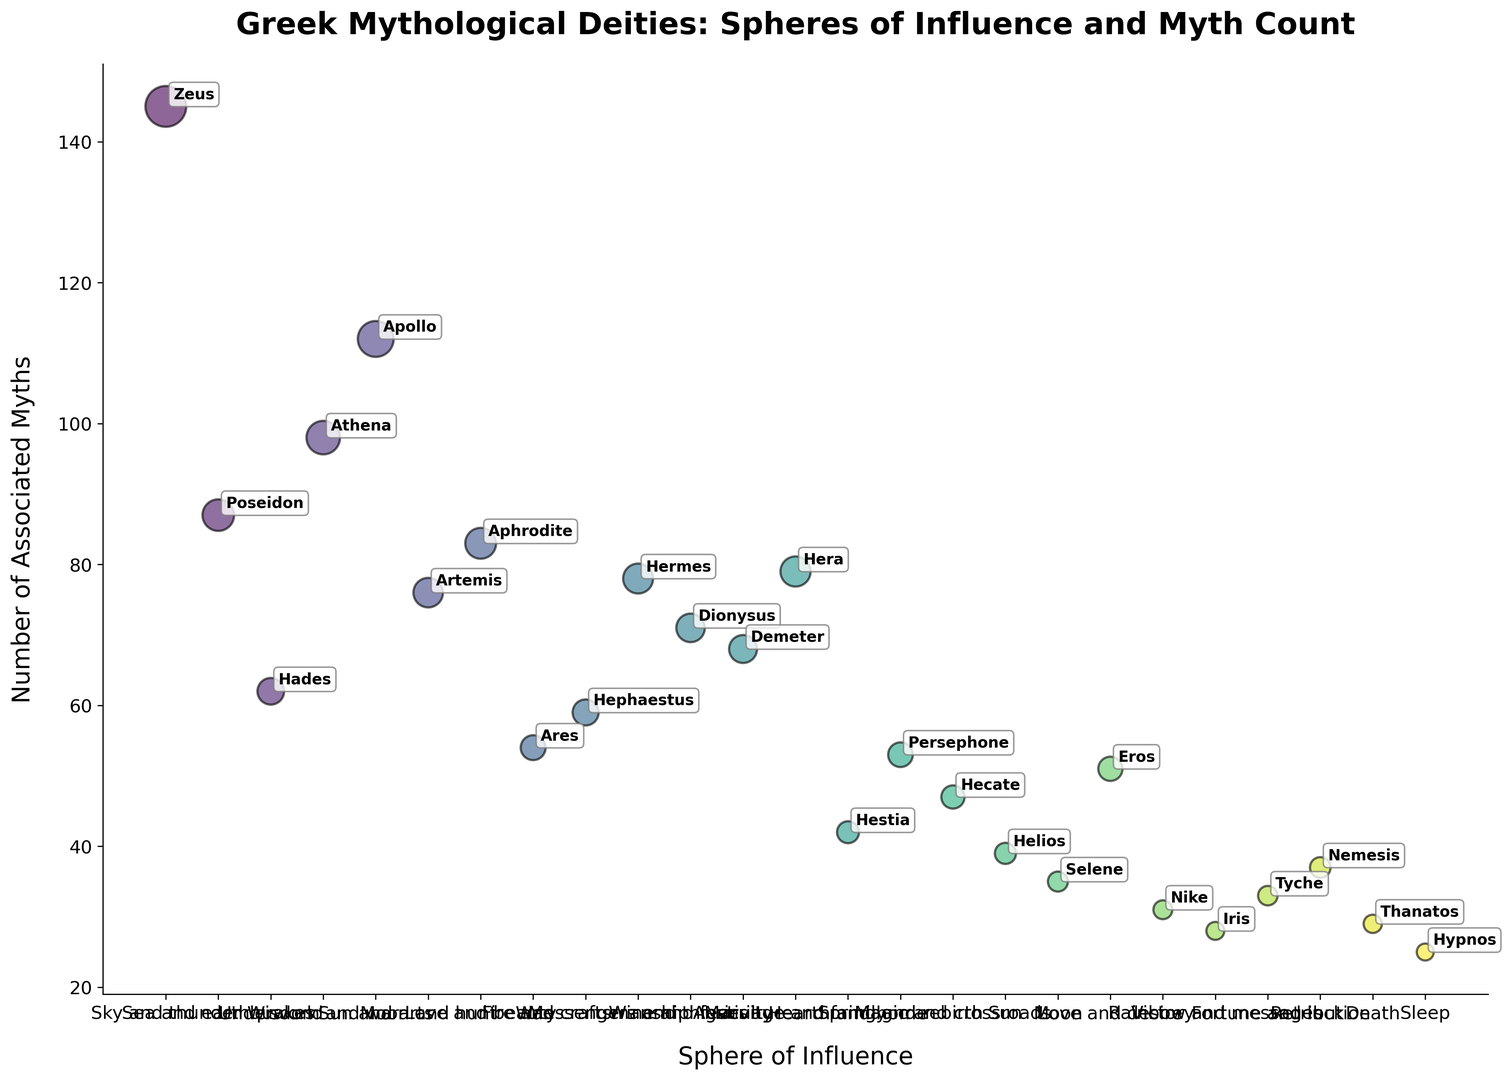Which deity has the highest number of associated myths? By looking at the bubble chart, the size and position of the bubble representing myth count indicate that Zeus has the highest number of associated myths.
Answer: Zeus Which sphere of influence has a deity with the lowest number of myths? By examining the smallest bubble in terms of myth count, we can see that Hypnos, representing Sleep, has the lowest number of associated myths.
Answer: Sleep How many myths are associated with Artemis compared to Aphrodite? By comparing the myth counts for Artemis and Aphrodite from the chart, we can see that Artemis has 76 myths while Aphrodite has 83. So, the difference is 83 - 76.
Answer: 7 Which deities are associated with the spheres of influence related to love and beauty? The chart shows that Aphrodite (Love and beauty) and Eros (Love and desire) are associated with spheres of influence related to love and beauty.
Answer: Aphrodite and Eros Who has more associated myths, Hades or Hermes? By comparing the bubble sizes and myth counts for Hades and Hermes, we can see that Hermes has 78 myths while Hades has 62.
Answer: Hermes What is the combined myth count for all deities associated with war? Adding up the myth counts for Ares (54) and Athena (98), who are both associated with war, gives us a combined count of 54 + 98 = 152.
Answer: 152 Which deity associated with a celestial body has the fewest myths? By looking at the deities associated with celestial bodies (Helios, Selene), the smallest bubble is for Selene, who has 35 myths.
Answer: Selene What is the range of myth counts for all deities related to magic or the underworld? The myth counts for Hades (62), Hecate (47), and Thanatos (29) range from 29 to 62. The range is calculated as 62 - 29.
Answer: 33 Who is associated with more myths, Demeter or Dionysus? By examining the bubble chart, Demeter is associated with 68 myths, while Dionysus is associated with 71 myths.
Answer: Dionysus Which deities have myth counts greater than 80? Looking at the bubble sizes, the deities with myth counts greater than 80 are Zeus (145), Apollo (112), and Athena (98).
Answer: Zeus, Apollo, and Athena 